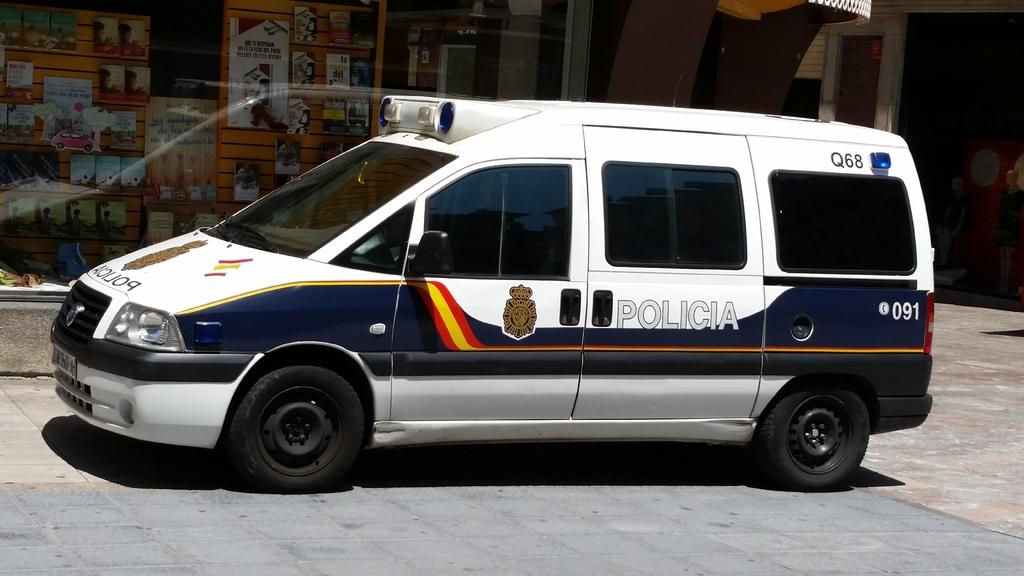What type of vehicle is in the image? There is a vehicle in the image, but the specific type is not mentioned. What colors are used for the vehicle? The vehicle is white and blue in color. What can be seen in the background of the image? There is a building and stores visible in the background. What is the color of the building? The building is cream-colored. Can you see any wings on the vehicle in the image? There are no wings visible on the vehicle in the image. What message of peace is being conveyed by the vehicle in the image? There is no message of peace mentioned or depicted in the image. 